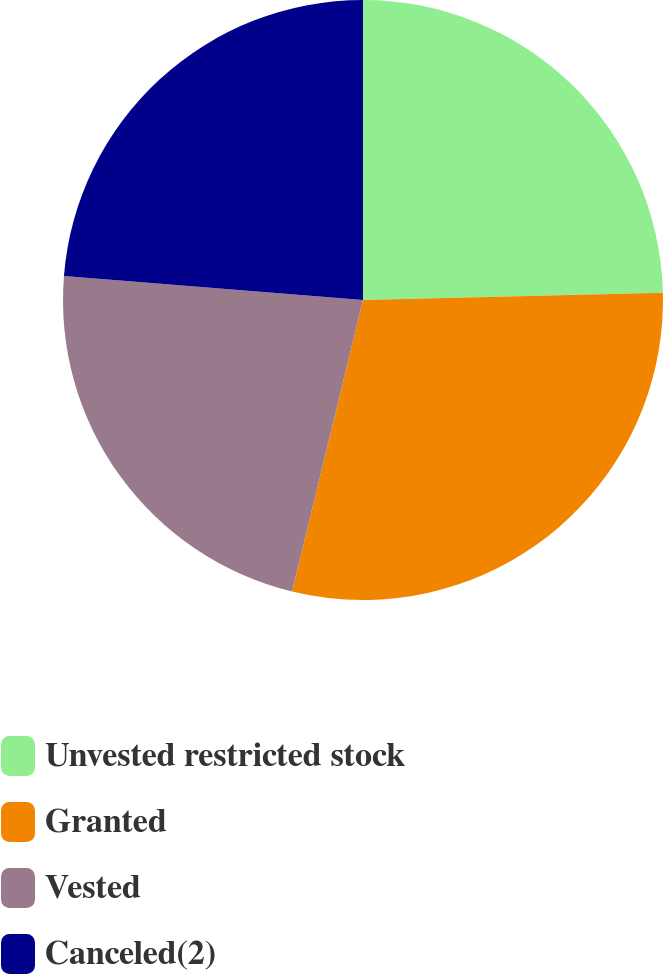Convert chart. <chart><loc_0><loc_0><loc_500><loc_500><pie_chart><fcel>Unvested restricted stock<fcel>Granted<fcel>Vested<fcel>Canceled(2)<nl><fcel>24.61%<fcel>29.19%<fcel>22.47%<fcel>23.73%<nl></chart> 